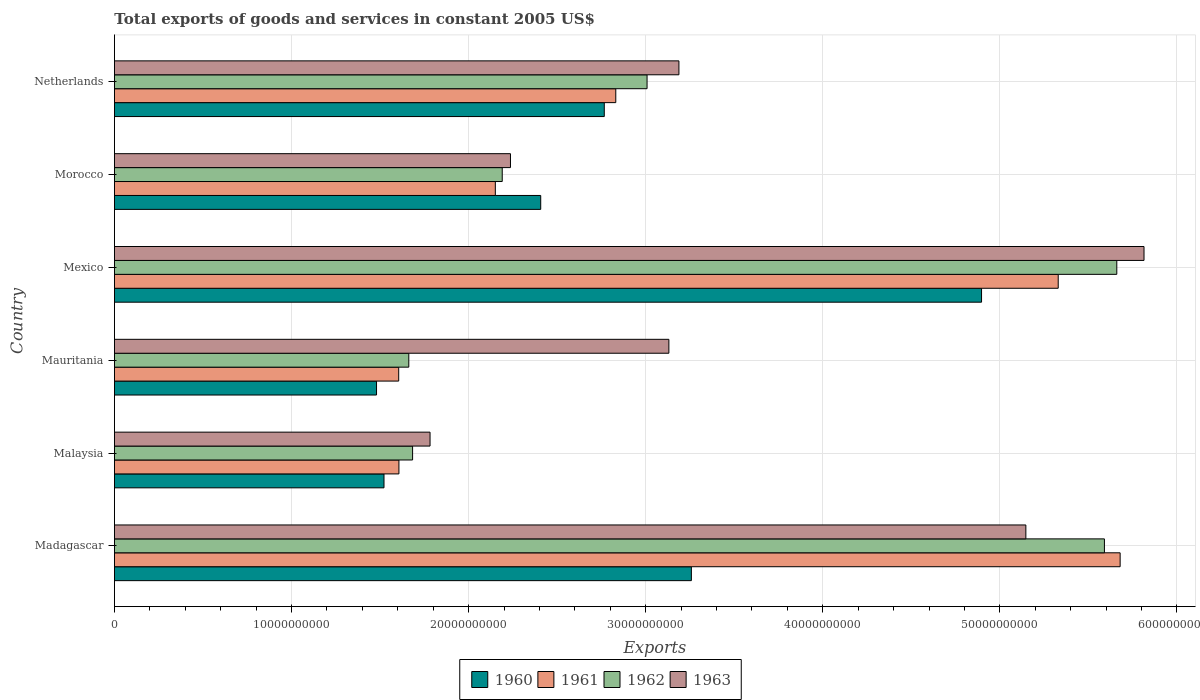Are the number of bars per tick equal to the number of legend labels?
Give a very brief answer. Yes. Are the number of bars on each tick of the Y-axis equal?
Ensure brevity in your answer.  Yes. How many bars are there on the 4th tick from the top?
Give a very brief answer. 4. How many bars are there on the 4th tick from the bottom?
Provide a short and direct response. 4. What is the label of the 3rd group of bars from the top?
Your response must be concise. Mexico. What is the total exports of goods and services in 1961 in Morocco?
Ensure brevity in your answer.  2.15e+1. Across all countries, what is the maximum total exports of goods and services in 1961?
Offer a terse response. 5.68e+1. Across all countries, what is the minimum total exports of goods and services in 1962?
Offer a terse response. 1.66e+1. In which country was the total exports of goods and services in 1963 maximum?
Ensure brevity in your answer.  Mexico. In which country was the total exports of goods and services in 1960 minimum?
Keep it short and to the point. Mauritania. What is the total total exports of goods and services in 1961 in the graph?
Keep it short and to the point. 1.92e+11. What is the difference between the total exports of goods and services in 1963 in Malaysia and that in Netherlands?
Offer a very short reply. -1.41e+1. What is the difference between the total exports of goods and services in 1962 in Mauritania and the total exports of goods and services in 1960 in Mexico?
Keep it short and to the point. -3.23e+1. What is the average total exports of goods and services in 1960 per country?
Make the answer very short. 2.72e+1. What is the difference between the total exports of goods and services in 1961 and total exports of goods and services in 1960 in Malaysia?
Provide a short and direct response. 8.42e+08. In how many countries, is the total exports of goods and services in 1963 greater than 30000000000 US$?
Your answer should be compact. 4. What is the ratio of the total exports of goods and services in 1960 in Mexico to that in Netherlands?
Provide a short and direct response. 1.77. Is the total exports of goods and services in 1960 in Malaysia less than that in Netherlands?
Your response must be concise. Yes. What is the difference between the highest and the second highest total exports of goods and services in 1962?
Give a very brief answer. 6.99e+08. What is the difference between the highest and the lowest total exports of goods and services in 1961?
Offer a very short reply. 4.07e+1. In how many countries, is the total exports of goods and services in 1962 greater than the average total exports of goods and services in 1962 taken over all countries?
Keep it short and to the point. 2. Is the sum of the total exports of goods and services in 1963 in Madagascar and Netherlands greater than the maximum total exports of goods and services in 1960 across all countries?
Your answer should be very brief. Yes. Is it the case that in every country, the sum of the total exports of goods and services in 1963 and total exports of goods and services in 1960 is greater than the sum of total exports of goods and services in 1962 and total exports of goods and services in 1961?
Your answer should be very brief. No. How many bars are there?
Your answer should be compact. 24. Where does the legend appear in the graph?
Keep it short and to the point. Bottom center. What is the title of the graph?
Your response must be concise. Total exports of goods and services in constant 2005 US$. Does "1990" appear as one of the legend labels in the graph?
Provide a succinct answer. No. What is the label or title of the X-axis?
Keep it short and to the point. Exports. What is the label or title of the Y-axis?
Keep it short and to the point. Country. What is the Exports of 1960 in Madagascar?
Give a very brief answer. 3.26e+1. What is the Exports in 1961 in Madagascar?
Provide a succinct answer. 5.68e+1. What is the Exports in 1962 in Madagascar?
Your answer should be very brief. 5.59e+1. What is the Exports in 1963 in Madagascar?
Your answer should be compact. 5.15e+1. What is the Exports of 1960 in Malaysia?
Keep it short and to the point. 1.52e+1. What is the Exports of 1961 in Malaysia?
Give a very brief answer. 1.61e+1. What is the Exports of 1962 in Malaysia?
Provide a succinct answer. 1.68e+1. What is the Exports of 1963 in Malaysia?
Keep it short and to the point. 1.78e+1. What is the Exports of 1960 in Mauritania?
Provide a succinct answer. 1.48e+1. What is the Exports in 1961 in Mauritania?
Your answer should be compact. 1.61e+1. What is the Exports in 1962 in Mauritania?
Keep it short and to the point. 1.66e+1. What is the Exports in 1963 in Mauritania?
Offer a terse response. 3.13e+1. What is the Exports of 1960 in Mexico?
Give a very brief answer. 4.90e+1. What is the Exports in 1961 in Mexico?
Offer a very short reply. 5.33e+1. What is the Exports in 1962 in Mexico?
Your answer should be compact. 5.66e+1. What is the Exports in 1963 in Mexico?
Offer a terse response. 5.81e+1. What is the Exports in 1960 in Morocco?
Provide a short and direct response. 2.41e+1. What is the Exports in 1961 in Morocco?
Your answer should be compact. 2.15e+1. What is the Exports of 1962 in Morocco?
Ensure brevity in your answer.  2.19e+1. What is the Exports of 1963 in Morocco?
Provide a short and direct response. 2.24e+1. What is the Exports in 1960 in Netherlands?
Keep it short and to the point. 2.77e+1. What is the Exports in 1961 in Netherlands?
Offer a very short reply. 2.83e+1. What is the Exports in 1962 in Netherlands?
Make the answer very short. 3.01e+1. What is the Exports in 1963 in Netherlands?
Give a very brief answer. 3.19e+1. Across all countries, what is the maximum Exports of 1960?
Offer a very short reply. 4.90e+1. Across all countries, what is the maximum Exports in 1961?
Offer a terse response. 5.68e+1. Across all countries, what is the maximum Exports of 1962?
Your response must be concise. 5.66e+1. Across all countries, what is the maximum Exports of 1963?
Your answer should be very brief. 5.81e+1. Across all countries, what is the minimum Exports in 1960?
Your answer should be compact. 1.48e+1. Across all countries, what is the minimum Exports in 1961?
Your answer should be compact. 1.61e+1. Across all countries, what is the minimum Exports of 1962?
Offer a terse response. 1.66e+1. Across all countries, what is the minimum Exports of 1963?
Offer a very short reply. 1.78e+1. What is the total Exports in 1960 in the graph?
Keep it short and to the point. 1.63e+11. What is the total Exports in 1961 in the graph?
Ensure brevity in your answer.  1.92e+11. What is the total Exports in 1962 in the graph?
Your answer should be very brief. 1.98e+11. What is the total Exports of 1963 in the graph?
Make the answer very short. 2.13e+11. What is the difference between the Exports in 1960 in Madagascar and that in Malaysia?
Offer a terse response. 1.74e+1. What is the difference between the Exports in 1961 in Madagascar and that in Malaysia?
Offer a very short reply. 4.07e+1. What is the difference between the Exports of 1962 in Madagascar and that in Malaysia?
Your answer should be very brief. 3.91e+1. What is the difference between the Exports in 1963 in Madagascar and that in Malaysia?
Your response must be concise. 3.36e+1. What is the difference between the Exports of 1960 in Madagascar and that in Mauritania?
Your answer should be compact. 1.78e+1. What is the difference between the Exports in 1961 in Madagascar and that in Mauritania?
Your answer should be compact. 4.07e+1. What is the difference between the Exports in 1962 in Madagascar and that in Mauritania?
Ensure brevity in your answer.  3.93e+1. What is the difference between the Exports in 1963 in Madagascar and that in Mauritania?
Give a very brief answer. 2.02e+1. What is the difference between the Exports of 1960 in Madagascar and that in Mexico?
Give a very brief answer. -1.64e+1. What is the difference between the Exports in 1961 in Madagascar and that in Mexico?
Your answer should be very brief. 3.50e+09. What is the difference between the Exports in 1962 in Madagascar and that in Mexico?
Make the answer very short. -6.99e+08. What is the difference between the Exports of 1963 in Madagascar and that in Mexico?
Make the answer very short. -6.67e+09. What is the difference between the Exports of 1960 in Madagascar and that in Morocco?
Your response must be concise. 8.51e+09. What is the difference between the Exports in 1961 in Madagascar and that in Morocco?
Give a very brief answer. 3.53e+1. What is the difference between the Exports in 1962 in Madagascar and that in Morocco?
Make the answer very short. 3.40e+1. What is the difference between the Exports in 1963 in Madagascar and that in Morocco?
Give a very brief answer. 2.91e+1. What is the difference between the Exports of 1960 in Madagascar and that in Netherlands?
Give a very brief answer. 4.92e+09. What is the difference between the Exports in 1961 in Madagascar and that in Netherlands?
Make the answer very short. 2.85e+1. What is the difference between the Exports of 1962 in Madagascar and that in Netherlands?
Offer a very short reply. 2.58e+1. What is the difference between the Exports in 1963 in Madagascar and that in Netherlands?
Offer a terse response. 1.96e+1. What is the difference between the Exports in 1960 in Malaysia and that in Mauritania?
Offer a very short reply. 4.22e+08. What is the difference between the Exports of 1961 in Malaysia and that in Mauritania?
Make the answer very short. 1.20e+07. What is the difference between the Exports in 1962 in Malaysia and that in Mauritania?
Provide a succinct answer. 2.15e+08. What is the difference between the Exports in 1963 in Malaysia and that in Mauritania?
Give a very brief answer. -1.35e+1. What is the difference between the Exports of 1960 in Malaysia and that in Mexico?
Keep it short and to the point. -3.37e+1. What is the difference between the Exports of 1961 in Malaysia and that in Mexico?
Give a very brief answer. -3.72e+1. What is the difference between the Exports of 1962 in Malaysia and that in Mexico?
Ensure brevity in your answer.  -3.98e+1. What is the difference between the Exports in 1963 in Malaysia and that in Mexico?
Give a very brief answer. -4.03e+1. What is the difference between the Exports in 1960 in Malaysia and that in Morocco?
Ensure brevity in your answer.  -8.85e+09. What is the difference between the Exports of 1961 in Malaysia and that in Morocco?
Your answer should be very brief. -5.44e+09. What is the difference between the Exports in 1962 in Malaysia and that in Morocco?
Give a very brief answer. -5.06e+09. What is the difference between the Exports of 1963 in Malaysia and that in Morocco?
Your response must be concise. -4.54e+09. What is the difference between the Exports of 1960 in Malaysia and that in Netherlands?
Your answer should be very brief. -1.24e+1. What is the difference between the Exports of 1961 in Malaysia and that in Netherlands?
Make the answer very short. -1.22e+1. What is the difference between the Exports in 1962 in Malaysia and that in Netherlands?
Keep it short and to the point. -1.32e+1. What is the difference between the Exports of 1963 in Malaysia and that in Netherlands?
Provide a succinct answer. -1.41e+1. What is the difference between the Exports in 1960 in Mauritania and that in Mexico?
Provide a short and direct response. -3.42e+1. What is the difference between the Exports of 1961 in Mauritania and that in Mexico?
Give a very brief answer. -3.72e+1. What is the difference between the Exports in 1962 in Mauritania and that in Mexico?
Make the answer very short. -4.00e+1. What is the difference between the Exports in 1963 in Mauritania and that in Mexico?
Provide a succinct answer. -2.68e+1. What is the difference between the Exports of 1960 in Mauritania and that in Morocco?
Provide a succinct answer. -9.27e+09. What is the difference between the Exports of 1961 in Mauritania and that in Morocco?
Your answer should be very brief. -5.46e+09. What is the difference between the Exports of 1962 in Mauritania and that in Morocco?
Offer a terse response. -5.28e+09. What is the difference between the Exports in 1963 in Mauritania and that in Morocco?
Your answer should be very brief. 8.95e+09. What is the difference between the Exports in 1960 in Mauritania and that in Netherlands?
Provide a succinct answer. -1.29e+1. What is the difference between the Exports of 1961 in Mauritania and that in Netherlands?
Ensure brevity in your answer.  -1.23e+1. What is the difference between the Exports in 1962 in Mauritania and that in Netherlands?
Your response must be concise. -1.35e+1. What is the difference between the Exports in 1963 in Mauritania and that in Netherlands?
Make the answer very short. -5.67e+08. What is the difference between the Exports of 1960 in Mexico and that in Morocco?
Your answer should be compact. 2.49e+1. What is the difference between the Exports of 1961 in Mexico and that in Morocco?
Keep it short and to the point. 3.18e+1. What is the difference between the Exports in 1962 in Mexico and that in Morocco?
Offer a terse response. 3.47e+1. What is the difference between the Exports in 1963 in Mexico and that in Morocco?
Keep it short and to the point. 3.58e+1. What is the difference between the Exports in 1960 in Mexico and that in Netherlands?
Give a very brief answer. 2.13e+1. What is the difference between the Exports in 1961 in Mexico and that in Netherlands?
Offer a very short reply. 2.50e+1. What is the difference between the Exports of 1962 in Mexico and that in Netherlands?
Provide a succinct answer. 2.65e+1. What is the difference between the Exports in 1963 in Mexico and that in Netherlands?
Ensure brevity in your answer.  2.63e+1. What is the difference between the Exports of 1960 in Morocco and that in Netherlands?
Provide a short and direct response. -3.59e+09. What is the difference between the Exports in 1961 in Morocco and that in Netherlands?
Ensure brevity in your answer.  -6.80e+09. What is the difference between the Exports in 1962 in Morocco and that in Netherlands?
Offer a terse response. -8.18e+09. What is the difference between the Exports of 1963 in Morocco and that in Netherlands?
Give a very brief answer. -9.51e+09. What is the difference between the Exports in 1960 in Madagascar and the Exports in 1961 in Malaysia?
Ensure brevity in your answer.  1.65e+1. What is the difference between the Exports of 1960 in Madagascar and the Exports of 1962 in Malaysia?
Your answer should be compact. 1.57e+1. What is the difference between the Exports in 1960 in Madagascar and the Exports in 1963 in Malaysia?
Keep it short and to the point. 1.48e+1. What is the difference between the Exports in 1961 in Madagascar and the Exports in 1962 in Malaysia?
Ensure brevity in your answer.  4.00e+1. What is the difference between the Exports in 1961 in Madagascar and the Exports in 1963 in Malaysia?
Keep it short and to the point. 3.90e+1. What is the difference between the Exports of 1962 in Madagascar and the Exports of 1963 in Malaysia?
Keep it short and to the point. 3.81e+1. What is the difference between the Exports in 1960 in Madagascar and the Exports in 1961 in Mauritania?
Your answer should be compact. 1.65e+1. What is the difference between the Exports of 1960 in Madagascar and the Exports of 1962 in Mauritania?
Offer a very short reply. 1.60e+1. What is the difference between the Exports of 1960 in Madagascar and the Exports of 1963 in Mauritania?
Provide a short and direct response. 1.27e+09. What is the difference between the Exports of 1961 in Madagascar and the Exports of 1962 in Mauritania?
Keep it short and to the point. 4.02e+1. What is the difference between the Exports in 1961 in Madagascar and the Exports in 1963 in Mauritania?
Keep it short and to the point. 2.55e+1. What is the difference between the Exports of 1962 in Madagascar and the Exports of 1963 in Mauritania?
Offer a very short reply. 2.46e+1. What is the difference between the Exports of 1960 in Madagascar and the Exports of 1961 in Mexico?
Provide a short and direct response. -2.07e+1. What is the difference between the Exports in 1960 in Madagascar and the Exports in 1962 in Mexico?
Provide a succinct answer. -2.40e+1. What is the difference between the Exports in 1960 in Madagascar and the Exports in 1963 in Mexico?
Make the answer very short. -2.56e+1. What is the difference between the Exports of 1961 in Madagascar and the Exports of 1962 in Mexico?
Offer a terse response. 1.89e+08. What is the difference between the Exports in 1961 in Madagascar and the Exports in 1963 in Mexico?
Offer a terse response. -1.35e+09. What is the difference between the Exports of 1962 in Madagascar and the Exports of 1963 in Mexico?
Your answer should be very brief. -2.24e+09. What is the difference between the Exports in 1960 in Madagascar and the Exports in 1961 in Morocco?
Provide a succinct answer. 1.11e+1. What is the difference between the Exports in 1960 in Madagascar and the Exports in 1962 in Morocco?
Provide a short and direct response. 1.07e+1. What is the difference between the Exports in 1960 in Madagascar and the Exports in 1963 in Morocco?
Offer a terse response. 1.02e+1. What is the difference between the Exports of 1961 in Madagascar and the Exports of 1962 in Morocco?
Provide a short and direct response. 3.49e+1. What is the difference between the Exports of 1961 in Madagascar and the Exports of 1963 in Morocco?
Provide a short and direct response. 3.44e+1. What is the difference between the Exports of 1962 in Madagascar and the Exports of 1963 in Morocco?
Offer a very short reply. 3.35e+1. What is the difference between the Exports in 1960 in Madagascar and the Exports in 1961 in Netherlands?
Offer a very short reply. 4.27e+09. What is the difference between the Exports of 1960 in Madagascar and the Exports of 1962 in Netherlands?
Provide a short and direct response. 2.50e+09. What is the difference between the Exports of 1960 in Madagascar and the Exports of 1963 in Netherlands?
Make the answer very short. 7.03e+08. What is the difference between the Exports in 1961 in Madagascar and the Exports in 1962 in Netherlands?
Give a very brief answer. 2.67e+1. What is the difference between the Exports in 1961 in Madagascar and the Exports in 1963 in Netherlands?
Your answer should be very brief. 2.49e+1. What is the difference between the Exports of 1962 in Madagascar and the Exports of 1963 in Netherlands?
Provide a short and direct response. 2.40e+1. What is the difference between the Exports in 1960 in Malaysia and the Exports in 1961 in Mauritania?
Your response must be concise. -8.31e+08. What is the difference between the Exports of 1960 in Malaysia and the Exports of 1962 in Mauritania?
Provide a short and direct response. -1.40e+09. What is the difference between the Exports in 1960 in Malaysia and the Exports in 1963 in Mauritania?
Make the answer very short. -1.61e+1. What is the difference between the Exports in 1961 in Malaysia and the Exports in 1962 in Mauritania?
Provide a succinct answer. -5.57e+08. What is the difference between the Exports of 1961 in Malaysia and the Exports of 1963 in Mauritania?
Keep it short and to the point. -1.52e+1. What is the difference between the Exports of 1962 in Malaysia and the Exports of 1963 in Mauritania?
Offer a very short reply. -1.45e+1. What is the difference between the Exports in 1960 in Malaysia and the Exports in 1961 in Mexico?
Your answer should be very brief. -3.81e+1. What is the difference between the Exports of 1960 in Malaysia and the Exports of 1962 in Mexico?
Give a very brief answer. -4.14e+1. What is the difference between the Exports of 1960 in Malaysia and the Exports of 1963 in Mexico?
Give a very brief answer. -4.29e+1. What is the difference between the Exports of 1961 in Malaysia and the Exports of 1962 in Mexico?
Offer a very short reply. -4.05e+1. What is the difference between the Exports of 1961 in Malaysia and the Exports of 1963 in Mexico?
Ensure brevity in your answer.  -4.21e+1. What is the difference between the Exports in 1962 in Malaysia and the Exports in 1963 in Mexico?
Your answer should be very brief. -4.13e+1. What is the difference between the Exports of 1960 in Malaysia and the Exports of 1961 in Morocco?
Keep it short and to the point. -6.29e+09. What is the difference between the Exports of 1960 in Malaysia and the Exports of 1962 in Morocco?
Offer a terse response. -6.68e+09. What is the difference between the Exports in 1960 in Malaysia and the Exports in 1963 in Morocco?
Your answer should be compact. -7.14e+09. What is the difference between the Exports in 1961 in Malaysia and the Exports in 1962 in Morocco?
Give a very brief answer. -5.83e+09. What is the difference between the Exports of 1961 in Malaysia and the Exports of 1963 in Morocco?
Your answer should be compact. -6.30e+09. What is the difference between the Exports in 1962 in Malaysia and the Exports in 1963 in Morocco?
Provide a short and direct response. -5.53e+09. What is the difference between the Exports of 1960 in Malaysia and the Exports of 1961 in Netherlands?
Your answer should be very brief. -1.31e+1. What is the difference between the Exports in 1960 in Malaysia and the Exports in 1962 in Netherlands?
Make the answer very short. -1.49e+1. What is the difference between the Exports of 1960 in Malaysia and the Exports of 1963 in Netherlands?
Provide a succinct answer. -1.67e+1. What is the difference between the Exports of 1961 in Malaysia and the Exports of 1962 in Netherlands?
Give a very brief answer. -1.40e+1. What is the difference between the Exports in 1961 in Malaysia and the Exports in 1963 in Netherlands?
Offer a terse response. -1.58e+1. What is the difference between the Exports of 1962 in Malaysia and the Exports of 1963 in Netherlands?
Offer a very short reply. -1.50e+1. What is the difference between the Exports of 1960 in Mauritania and the Exports of 1961 in Mexico?
Give a very brief answer. -3.85e+1. What is the difference between the Exports in 1960 in Mauritania and the Exports in 1962 in Mexico?
Offer a terse response. -4.18e+1. What is the difference between the Exports of 1960 in Mauritania and the Exports of 1963 in Mexico?
Offer a terse response. -4.33e+1. What is the difference between the Exports in 1961 in Mauritania and the Exports in 1962 in Mexico?
Give a very brief answer. -4.05e+1. What is the difference between the Exports of 1961 in Mauritania and the Exports of 1963 in Mexico?
Provide a succinct answer. -4.21e+1. What is the difference between the Exports in 1962 in Mauritania and the Exports in 1963 in Mexico?
Offer a very short reply. -4.15e+1. What is the difference between the Exports in 1960 in Mauritania and the Exports in 1961 in Morocco?
Keep it short and to the point. -6.71e+09. What is the difference between the Exports in 1960 in Mauritania and the Exports in 1962 in Morocco?
Your answer should be very brief. -7.10e+09. What is the difference between the Exports of 1960 in Mauritania and the Exports of 1963 in Morocco?
Provide a short and direct response. -7.56e+09. What is the difference between the Exports in 1961 in Mauritania and the Exports in 1962 in Morocco?
Ensure brevity in your answer.  -5.85e+09. What is the difference between the Exports in 1961 in Mauritania and the Exports in 1963 in Morocco?
Ensure brevity in your answer.  -6.31e+09. What is the difference between the Exports of 1962 in Mauritania and the Exports of 1963 in Morocco?
Give a very brief answer. -5.74e+09. What is the difference between the Exports in 1960 in Mauritania and the Exports in 1961 in Netherlands?
Your response must be concise. -1.35e+1. What is the difference between the Exports of 1960 in Mauritania and the Exports of 1962 in Netherlands?
Give a very brief answer. -1.53e+1. What is the difference between the Exports of 1960 in Mauritania and the Exports of 1963 in Netherlands?
Your answer should be very brief. -1.71e+1. What is the difference between the Exports of 1961 in Mauritania and the Exports of 1962 in Netherlands?
Give a very brief answer. -1.40e+1. What is the difference between the Exports of 1961 in Mauritania and the Exports of 1963 in Netherlands?
Keep it short and to the point. -1.58e+1. What is the difference between the Exports of 1962 in Mauritania and the Exports of 1963 in Netherlands?
Provide a succinct answer. -1.53e+1. What is the difference between the Exports in 1960 in Mexico and the Exports in 1961 in Morocco?
Give a very brief answer. 2.75e+1. What is the difference between the Exports in 1960 in Mexico and the Exports in 1962 in Morocco?
Make the answer very short. 2.71e+1. What is the difference between the Exports of 1960 in Mexico and the Exports of 1963 in Morocco?
Your answer should be very brief. 2.66e+1. What is the difference between the Exports in 1961 in Mexico and the Exports in 1962 in Morocco?
Make the answer very short. 3.14e+1. What is the difference between the Exports in 1961 in Mexico and the Exports in 1963 in Morocco?
Ensure brevity in your answer.  3.09e+1. What is the difference between the Exports in 1962 in Mexico and the Exports in 1963 in Morocco?
Provide a succinct answer. 3.42e+1. What is the difference between the Exports of 1960 in Mexico and the Exports of 1961 in Netherlands?
Offer a terse response. 2.07e+1. What is the difference between the Exports in 1960 in Mexico and the Exports in 1962 in Netherlands?
Provide a succinct answer. 1.89e+1. What is the difference between the Exports in 1960 in Mexico and the Exports in 1963 in Netherlands?
Give a very brief answer. 1.71e+1. What is the difference between the Exports of 1961 in Mexico and the Exports of 1962 in Netherlands?
Your answer should be very brief. 2.32e+1. What is the difference between the Exports in 1961 in Mexico and the Exports in 1963 in Netherlands?
Give a very brief answer. 2.14e+1. What is the difference between the Exports in 1962 in Mexico and the Exports in 1963 in Netherlands?
Offer a very short reply. 2.47e+1. What is the difference between the Exports in 1960 in Morocco and the Exports in 1961 in Netherlands?
Your answer should be very brief. -4.24e+09. What is the difference between the Exports of 1960 in Morocco and the Exports of 1962 in Netherlands?
Your answer should be compact. -6.01e+09. What is the difference between the Exports of 1960 in Morocco and the Exports of 1963 in Netherlands?
Offer a terse response. -7.80e+09. What is the difference between the Exports in 1961 in Morocco and the Exports in 1962 in Netherlands?
Provide a short and direct response. -8.57e+09. What is the difference between the Exports of 1961 in Morocco and the Exports of 1963 in Netherlands?
Offer a very short reply. -1.04e+1. What is the difference between the Exports of 1962 in Morocco and the Exports of 1963 in Netherlands?
Offer a very short reply. -9.98e+09. What is the average Exports of 1960 per country?
Provide a succinct answer. 2.72e+1. What is the average Exports of 1961 per country?
Give a very brief answer. 3.20e+1. What is the average Exports in 1962 per country?
Provide a short and direct response. 3.30e+1. What is the average Exports in 1963 per country?
Your answer should be compact. 3.55e+1. What is the difference between the Exports of 1960 and Exports of 1961 in Madagascar?
Provide a short and direct response. -2.42e+1. What is the difference between the Exports of 1960 and Exports of 1962 in Madagascar?
Keep it short and to the point. -2.33e+1. What is the difference between the Exports of 1960 and Exports of 1963 in Madagascar?
Your answer should be compact. -1.89e+1. What is the difference between the Exports of 1961 and Exports of 1962 in Madagascar?
Provide a short and direct response. 8.87e+08. What is the difference between the Exports of 1961 and Exports of 1963 in Madagascar?
Provide a short and direct response. 5.32e+09. What is the difference between the Exports of 1962 and Exports of 1963 in Madagascar?
Provide a short and direct response. 4.44e+09. What is the difference between the Exports of 1960 and Exports of 1961 in Malaysia?
Your answer should be very brief. -8.42e+08. What is the difference between the Exports in 1960 and Exports in 1962 in Malaysia?
Your response must be concise. -1.61e+09. What is the difference between the Exports in 1960 and Exports in 1963 in Malaysia?
Give a very brief answer. -2.60e+09. What is the difference between the Exports of 1961 and Exports of 1962 in Malaysia?
Your answer should be compact. -7.72e+08. What is the difference between the Exports of 1961 and Exports of 1963 in Malaysia?
Provide a succinct answer. -1.76e+09. What is the difference between the Exports in 1962 and Exports in 1963 in Malaysia?
Ensure brevity in your answer.  -9.85e+08. What is the difference between the Exports in 1960 and Exports in 1961 in Mauritania?
Your answer should be compact. -1.25e+09. What is the difference between the Exports of 1960 and Exports of 1962 in Mauritania?
Make the answer very short. -1.82e+09. What is the difference between the Exports in 1960 and Exports in 1963 in Mauritania?
Your answer should be compact. -1.65e+1. What is the difference between the Exports of 1961 and Exports of 1962 in Mauritania?
Offer a very short reply. -5.69e+08. What is the difference between the Exports of 1961 and Exports of 1963 in Mauritania?
Keep it short and to the point. -1.53e+1. What is the difference between the Exports in 1962 and Exports in 1963 in Mauritania?
Your answer should be compact. -1.47e+1. What is the difference between the Exports in 1960 and Exports in 1961 in Mexico?
Offer a terse response. -4.33e+09. What is the difference between the Exports of 1960 and Exports of 1962 in Mexico?
Make the answer very short. -7.64e+09. What is the difference between the Exports in 1960 and Exports in 1963 in Mexico?
Make the answer very short. -9.17e+09. What is the difference between the Exports of 1961 and Exports of 1962 in Mexico?
Offer a terse response. -3.31e+09. What is the difference between the Exports of 1961 and Exports of 1963 in Mexico?
Your answer should be very brief. -4.84e+09. What is the difference between the Exports in 1962 and Exports in 1963 in Mexico?
Make the answer very short. -1.54e+09. What is the difference between the Exports of 1960 and Exports of 1961 in Morocco?
Provide a short and direct response. 2.56e+09. What is the difference between the Exports in 1960 and Exports in 1962 in Morocco?
Your answer should be compact. 2.17e+09. What is the difference between the Exports of 1960 and Exports of 1963 in Morocco?
Ensure brevity in your answer.  1.71e+09. What is the difference between the Exports of 1961 and Exports of 1962 in Morocco?
Provide a succinct answer. -3.89e+08. What is the difference between the Exports in 1961 and Exports in 1963 in Morocco?
Your answer should be very brief. -8.54e+08. What is the difference between the Exports of 1962 and Exports of 1963 in Morocco?
Your answer should be very brief. -4.65e+08. What is the difference between the Exports of 1960 and Exports of 1961 in Netherlands?
Your answer should be compact. -6.49e+08. What is the difference between the Exports of 1960 and Exports of 1962 in Netherlands?
Your answer should be very brief. -2.42e+09. What is the difference between the Exports of 1960 and Exports of 1963 in Netherlands?
Your answer should be very brief. -4.21e+09. What is the difference between the Exports of 1961 and Exports of 1962 in Netherlands?
Offer a very short reply. -1.77e+09. What is the difference between the Exports in 1961 and Exports in 1963 in Netherlands?
Offer a very short reply. -3.57e+09. What is the difference between the Exports of 1962 and Exports of 1963 in Netherlands?
Keep it short and to the point. -1.80e+09. What is the ratio of the Exports in 1960 in Madagascar to that in Malaysia?
Give a very brief answer. 2.14. What is the ratio of the Exports of 1961 in Madagascar to that in Malaysia?
Provide a succinct answer. 3.54. What is the ratio of the Exports of 1962 in Madagascar to that in Malaysia?
Your response must be concise. 3.32. What is the ratio of the Exports of 1963 in Madagascar to that in Malaysia?
Ensure brevity in your answer.  2.89. What is the ratio of the Exports of 1960 in Madagascar to that in Mauritania?
Your answer should be compact. 2.2. What is the ratio of the Exports of 1961 in Madagascar to that in Mauritania?
Ensure brevity in your answer.  3.54. What is the ratio of the Exports of 1962 in Madagascar to that in Mauritania?
Provide a succinct answer. 3.36. What is the ratio of the Exports of 1963 in Madagascar to that in Mauritania?
Provide a short and direct response. 1.64. What is the ratio of the Exports in 1960 in Madagascar to that in Mexico?
Make the answer very short. 0.67. What is the ratio of the Exports of 1961 in Madagascar to that in Mexico?
Your answer should be compact. 1.07. What is the ratio of the Exports in 1962 in Madagascar to that in Mexico?
Your response must be concise. 0.99. What is the ratio of the Exports of 1963 in Madagascar to that in Mexico?
Your response must be concise. 0.89. What is the ratio of the Exports of 1960 in Madagascar to that in Morocco?
Give a very brief answer. 1.35. What is the ratio of the Exports in 1961 in Madagascar to that in Morocco?
Provide a short and direct response. 2.64. What is the ratio of the Exports in 1962 in Madagascar to that in Morocco?
Provide a succinct answer. 2.55. What is the ratio of the Exports of 1963 in Madagascar to that in Morocco?
Keep it short and to the point. 2.3. What is the ratio of the Exports in 1960 in Madagascar to that in Netherlands?
Make the answer very short. 1.18. What is the ratio of the Exports in 1961 in Madagascar to that in Netherlands?
Your answer should be very brief. 2.01. What is the ratio of the Exports of 1962 in Madagascar to that in Netherlands?
Offer a terse response. 1.86. What is the ratio of the Exports in 1963 in Madagascar to that in Netherlands?
Your answer should be compact. 1.61. What is the ratio of the Exports of 1960 in Malaysia to that in Mauritania?
Ensure brevity in your answer.  1.03. What is the ratio of the Exports of 1961 in Malaysia to that in Mauritania?
Ensure brevity in your answer.  1. What is the ratio of the Exports of 1962 in Malaysia to that in Mauritania?
Offer a terse response. 1.01. What is the ratio of the Exports in 1963 in Malaysia to that in Mauritania?
Give a very brief answer. 0.57. What is the ratio of the Exports in 1960 in Malaysia to that in Mexico?
Your answer should be compact. 0.31. What is the ratio of the Exports in 1961 in Malaysia to that in Mexico?
Make the answer very short. 0.3. What is the ratio of the Exports of 1962 in Malaysia to that in Mexico?
Give a very brief answer. 0.3. What is the ratio of the Exports of 1963 in Malaysia to that in Mexico?
Offer a terse response. 0.31. What is the ratio of the Exports of 1960 in Malaysia to that in Morocco?
Your answer should be very brief. 0.63. What is the ratio of the Exports of 1961 in Malaysia to that in Morocco?
Keep it short and to the point. 0.75. What is the ratio of the Exports of 1962 in Malaysia to that in Morocco?
Your answer should be very brief. 0.77. What is the ratio of the Exports in 1963 in Malaysia to that in Morocco?
Your answer should be very brief. 0.8. What is the ratio of the Exports in 1960 in Malaysia to that in Netherlands?
Offer a terse response. 0.55. What is the ratio of the Exports in 1961 in Malaysia to that in Netherlands?
Your answer should be compact. 0.57. What is the ratio of the Exports of 1962 in Malaysia to that in Netherlands?
Ensure brevity in your answer.  0.56. What is the ratio of the Exports of 1963 in Malaysia to that in Netherlands?
Make the answer very short. 0.56. What is the ratio of the Exports of 1960 in Mauritania to that in Mexico?
Ensure brevity in your answer.  0.3. What is the ratio of the Exports in 1961 in Mauritania to that in Mexico?
Make the answer very short. 0.3. What is the ratio of the Exports in 1962 in Mauritania to that in Mexico?
Provide a succinct answer. 0.29. What is the ratio of the Exports of 1963 in Mauritania to that in Mexico?
Give a very brief answer. 0.54. What is the ratio of the Exports of 1960 in Mauritania to that in Morocco?
Offer a terse response. 0.61. What is the ratio of the Exports in 1961 in Mauritania to that in Morocco?
Give a very brief answer. 0.75. What is the ratio of the Exports of 1962 in Mauritania to that in Morocco?
Provide a short and direct response. 0.76. What is the ratio of the Exports in 1963 in Mauritania to that in Morocco?
Give a very brief answer. 1.4. What is the ratio of the Exports in 1960 in Mauritania to that in Netherlands?
Ensure brevity in your answer.  0.54. What is the ratio of the Exports in 1961 in Mauritania to that in Netherlands?
Your response must be concise. 0.57. What is the ratio of the Exports of 1962 in Mauritania to that in Netherlands?
Provide a short and direct response. 0.55. What is the ratio of the Exports in 1963 in Mauritania to that in Netherlands?
Your response must be concise. 0.98. What is the ratio of the Exports in 1960 in Mexico to that in Morocco?
Your response must be concise. 2.03. What is the ratio of the Exports in 1961 in Mexico to that in Morocco?
Keep it short and to the point. 2.48. What is the ratio of the Exports of 1962 in Mexico to that in Morocco?
Give a very brief answer. 2.58. What is the ratio of the Exports in 1963 in Mexico to that in Morocco?
Give a very brief answer. 2.6. What is the ratio of the Exports in 1960 in Mexico to that in Netherlands?
Your answer should be compact. 1.77. What is the ratio of the Exports in 1961 in Mexico to that in Netherlands?
Make the answer very short. 1.88. What is the ratio of the Exports in 1962 in Mexico to that in Netherlands?
Provide a short and direct response. 1.88. What is the ratio of the Exports of 1963 in Mexico to that in Netherlands?
Keep it short and to the point. 1.82. What is the ratio of the Exports in 1960 in Morocco to that in Netherlands?
Provide a succinct answer. 0.87. What is the ratio of the Exports in 1961 in Morocco to that in Netherlands?
Ensure brevity in your answer.  0.76. What is the ratio of the Exports of 1962 in Morocco to that in Netherlands?
Provide a succinct answer. 0.73. What is the ratio of the Exports in 1963 in Morocco to that in Netherlands?
Your response must be concise. 0.7. What is the difference between the highest and the second highest Exports in 1960?
Make the answer very short. 1.64e+1. What is the difference between the highest and the second highest Exports of 1961?
Offer a terse response. 3.50e+09. What is the difference between the highest and the second highest Exports in 1962?
Keep it short and to the point. 6.99e+08. What is the difference between the highest and the second highest Exports in 1963?
Offer a very short reply. 6.67e+09. What is the difference between the highest and the lowest Exports in 1960?
Give a very brief answer. 3.42e+1. What is the difference between the highest and the lowest Exports of 1961?
Your answer should be compact. 4.07e+1. What is the difference between the highest and the lowest Exports of 1962?
Offer a terse response. 4.00e+1. What is the difference between the highest and the lowest Exports in 1963?
Offer a terse response. 4.03e+1. 